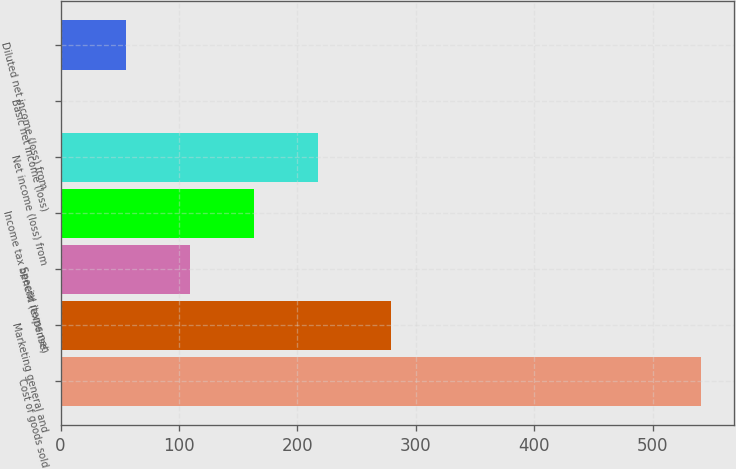Convert chart. <chart><loc_0><loc_0><loc_500><loc_500><bar_chart><fcel>Cost of goods sold<fcel>Marketing general and<fcel>Special items net<fcel>Income tax benefit (expense)<fcel>Net income (loss) from<fcel>Basic net income (loss)<fcel>Diluted net income (loss) from<nl><fcel>541.3<fcel>278.9<fcel>109.02<fcel>163.06<fcel>217.1<fcel>0.94<fcel>54.98<nl></chart> 